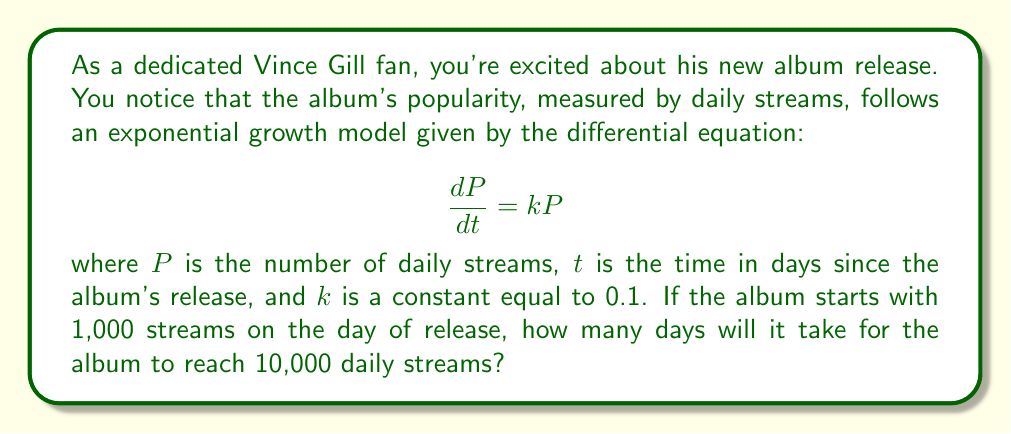Can you answer this question? To solve this problem, we'll use the exponential growth model and follow these steps:

1) The general solution to the differential equation $\frac{dP}{dt} = kP$ is:

   $$P(t) = P_0e^{kt}$$

   where $P_0$ is the initial number of streams.

2) We're given that $P_0 = 1,000$, $k = 0.1$, and we want to find $t$ when $P(t) = 10,000$.

3) Substituting these values into the equation:

   $$10,000 = 1,000e^{0.1t}$$

4) Dividing both sides by 1,000:

   $$10 = e^{0.1t}$$

5) Taking the natural logarithm of both sides:

   $$\ln(10) = 0.1t$$

6) Solving for $t$:

   $$t = \frac{\ln(10)}{0.1} \approx 23.03$$

7) Since we're dealing with days, we round up to the nearest whole day.
Answer: It will take 24 days for Vince Gill's new album to reach 10,000 daily streams. 